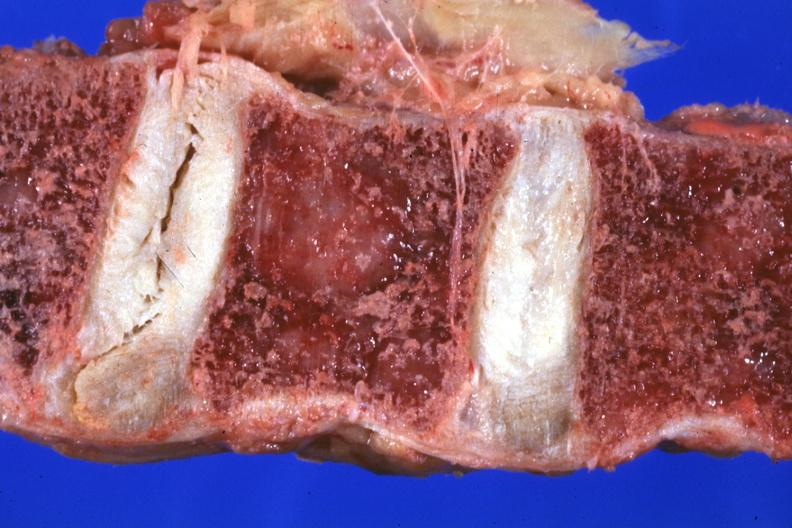what is present?
Answer the question using a single word or phrase. Joints 